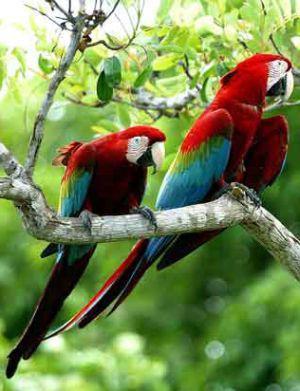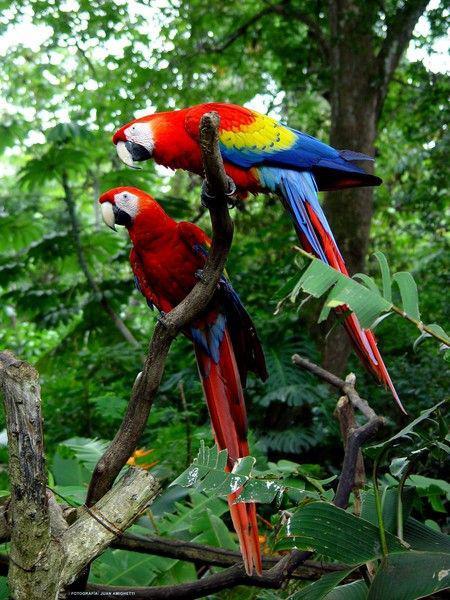The first image is the image on the left, the second image is the image on the right. Given the left and right images, does the statement "One of the birds in the right image has its wings spread." hold true? Answer yes or no. No. 